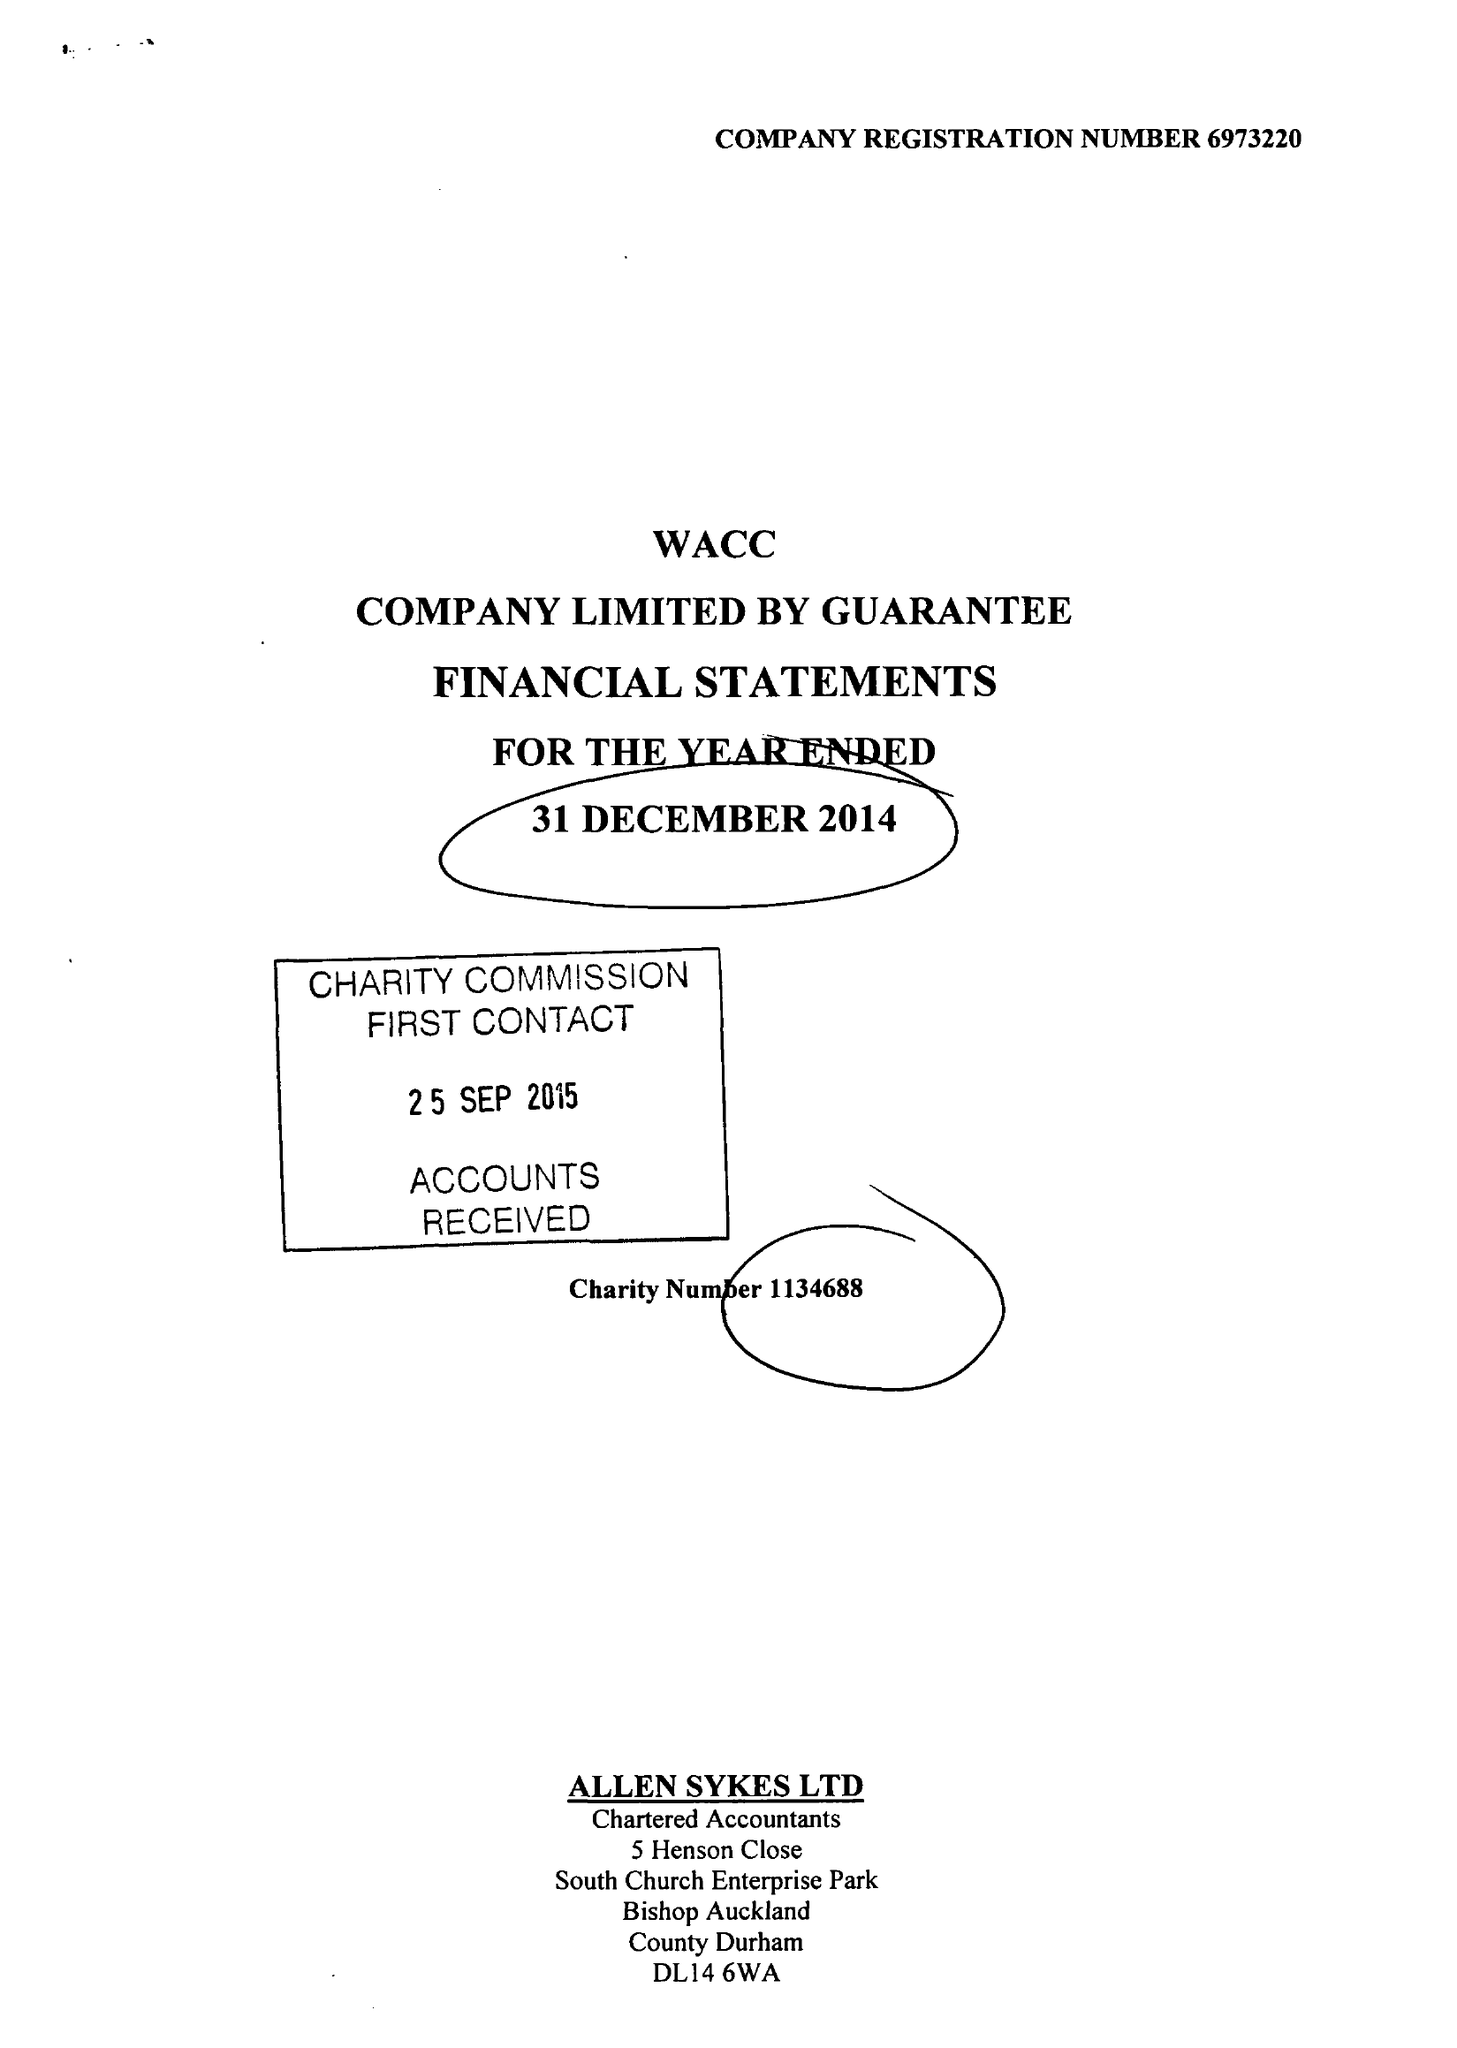What is the value for the spending_annually_in_british_pounds?
Answer the question using a single word or phrase. 57377.00 